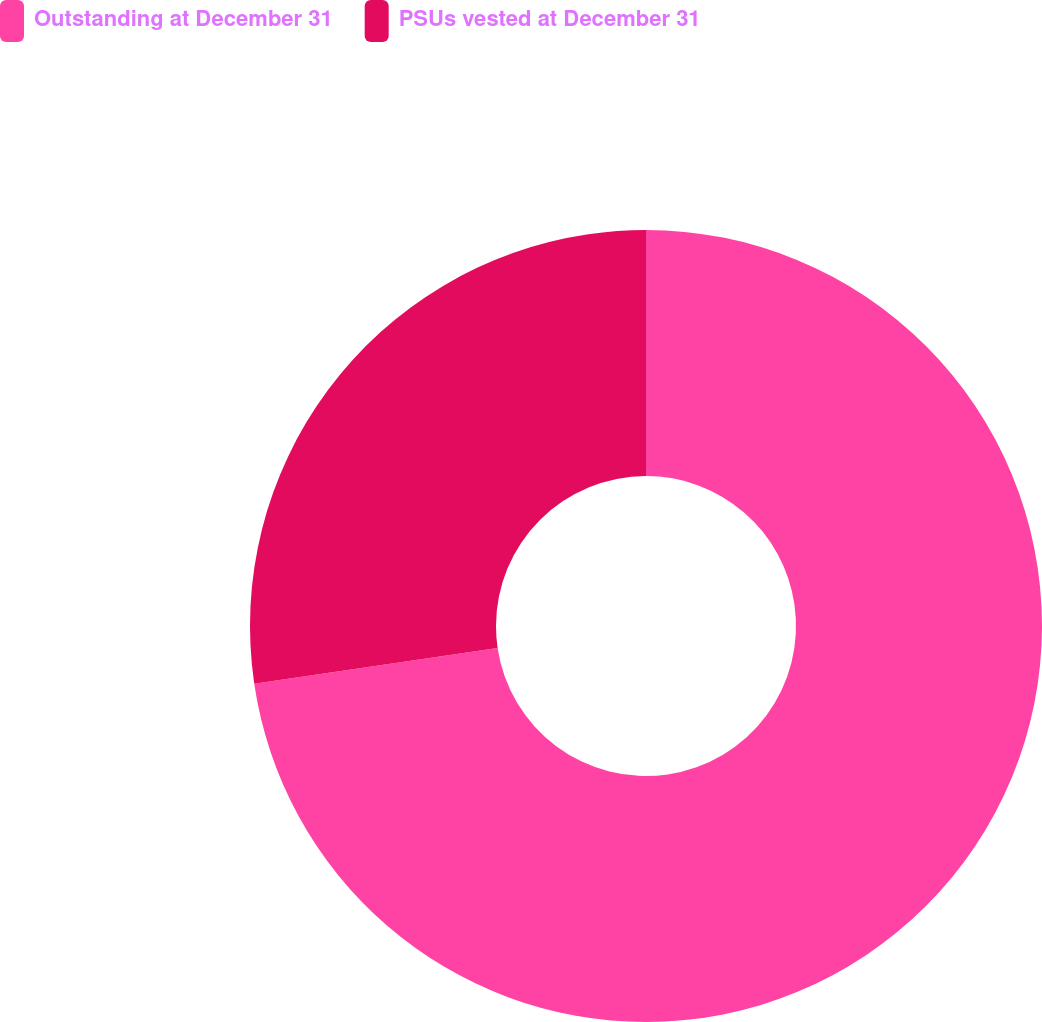Convert chart. <chart><loc_0><loc_0><loc_500><loc_500><pie_chart><fcel>Outstanding at December 31<fcel>PSUs vested at December 31<nl><fcel>72.67%<fcel>27.33%<nl></chart> 